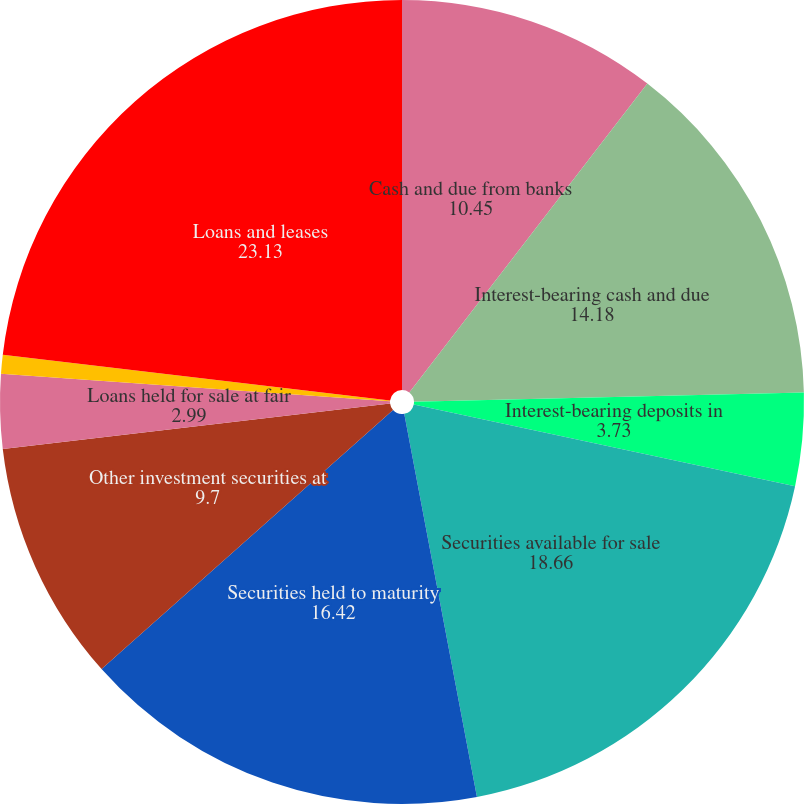Convert chart. <chart><loc_0><loc_0><loc_500><loc_500><pie_chart><fcel>Cash and due from banks<fcel>Interest-bearing cash and due<fcel>Interest-bearing deposits in<fcel>Securities available for sale<fcel>Securities held to maturity<fcel>Other investment securities at<fcel>Loans held for sale at fair<fcel>Other loans held for sale<fcel>Loans and leases<nl><fcel>10.45%<fcel>14.18%<fcel>3.73%<fcel>18.66%<fcel>16.42%<fcel>9.7%<fcel>2.99%<fcel>0.75%<fcel>23.13%<nl></chart> 